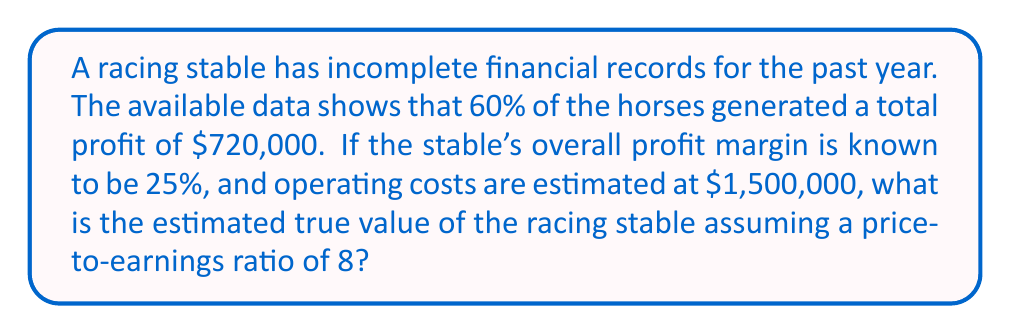What is the answer to this math problem? Let's approach this step-by-step:

1) First, we need to estimate the total profit for all horses:
   If 60% of horses generated $720,000, then 100% would generate:
   $$ \frac{720,000}{0.6} = 1,200,000 $$

2) Now, we know the profit margin is 25%. Let's call the total revenue $x$. Then:
   $$ \frac{\text{Profit}}{\text{Revenue}} = 0.25 $$
   $$ \frac{1,200,000}{x} = 0.25 $$

3) Solving for $x$:
   $$ x = \frac{1,200,000}{0.25} = 4,800,000 $$

4) To verify, let's check if this aligns with the given operating costs:
   Revenue - Profit - Operating Costs should equal zero
   $$ 4,800,000 - 1,200,000 - 1,500,000 = 2,100,000 $$
   This extra $2,100,000 likely accounts for other expenses not explicitly mentioned.

5) Now, to estimate the value of the stable, we use the price-to-earnings (P/E) ratio:
   Value = Earnings × P/E ratio
   $$ \text{Value} = 1,200,000 \times 8 = 9,600,000 $$

Therefore, the estimated true value of the racing stable is $9,600,000.
Answer: $9,600,000 